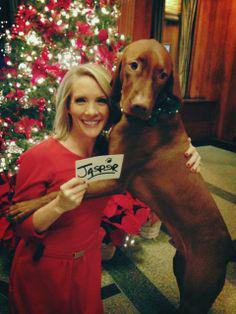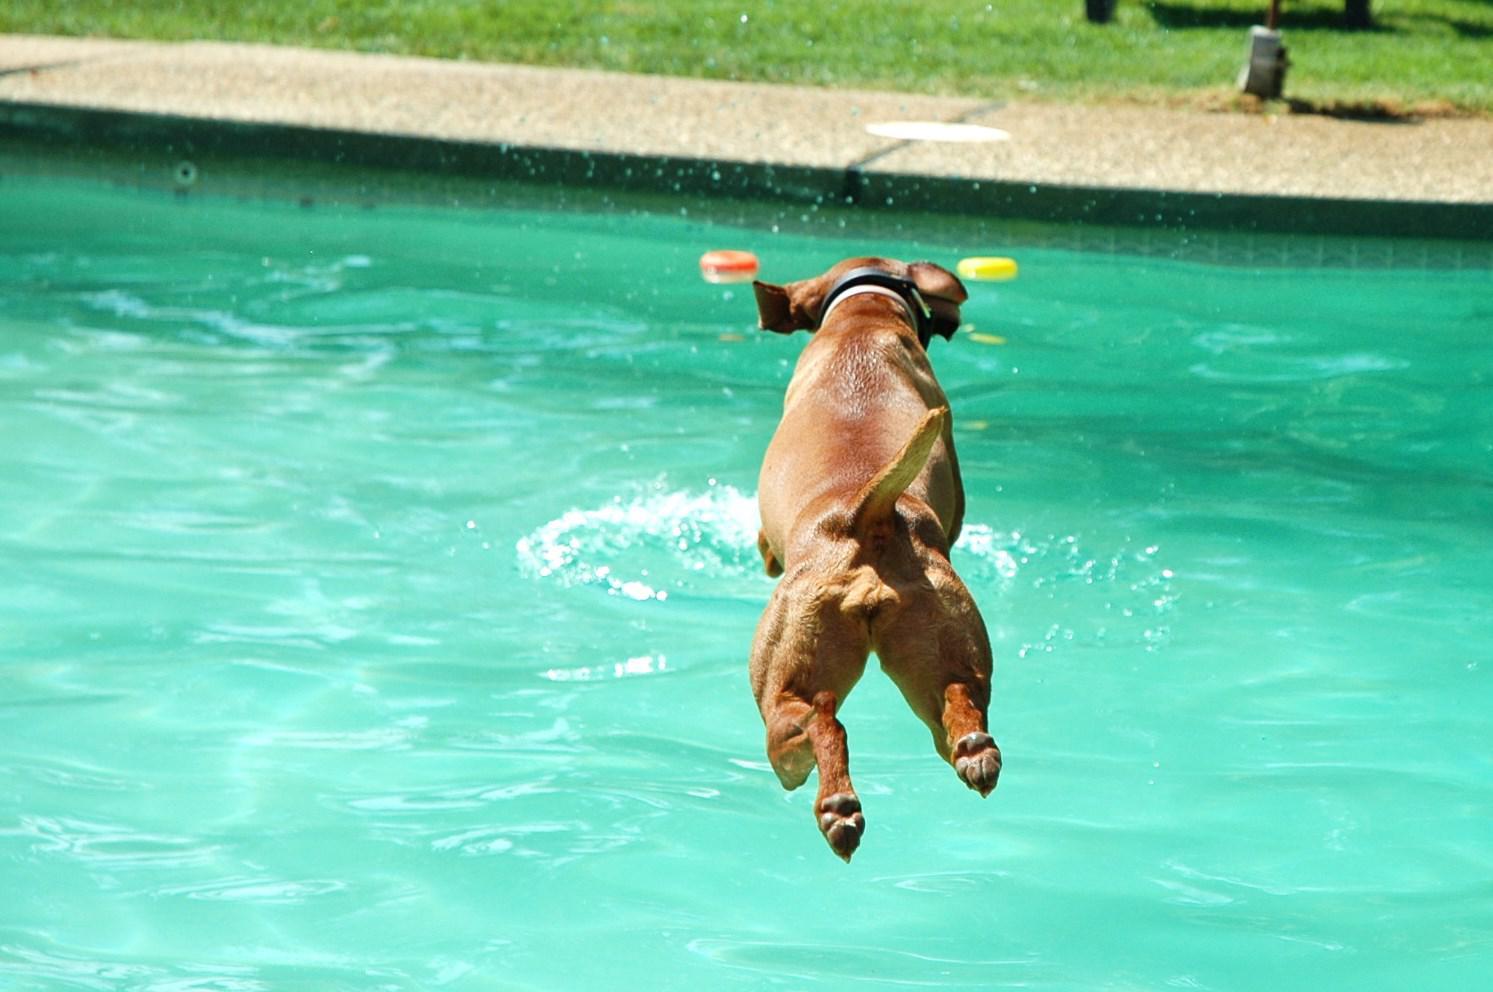The first image is the image on the left, the second image is the image on the right. Considering the images on both sides, is "One of the dogs is on a blue floating raft and looking to the right." valid? Answer yes or no. No. The first image is the image on the left, the second image is the image on the right. For the images shown, is this caption "A dog is leaping into the pool" true? Answer yes or no. Yes. 